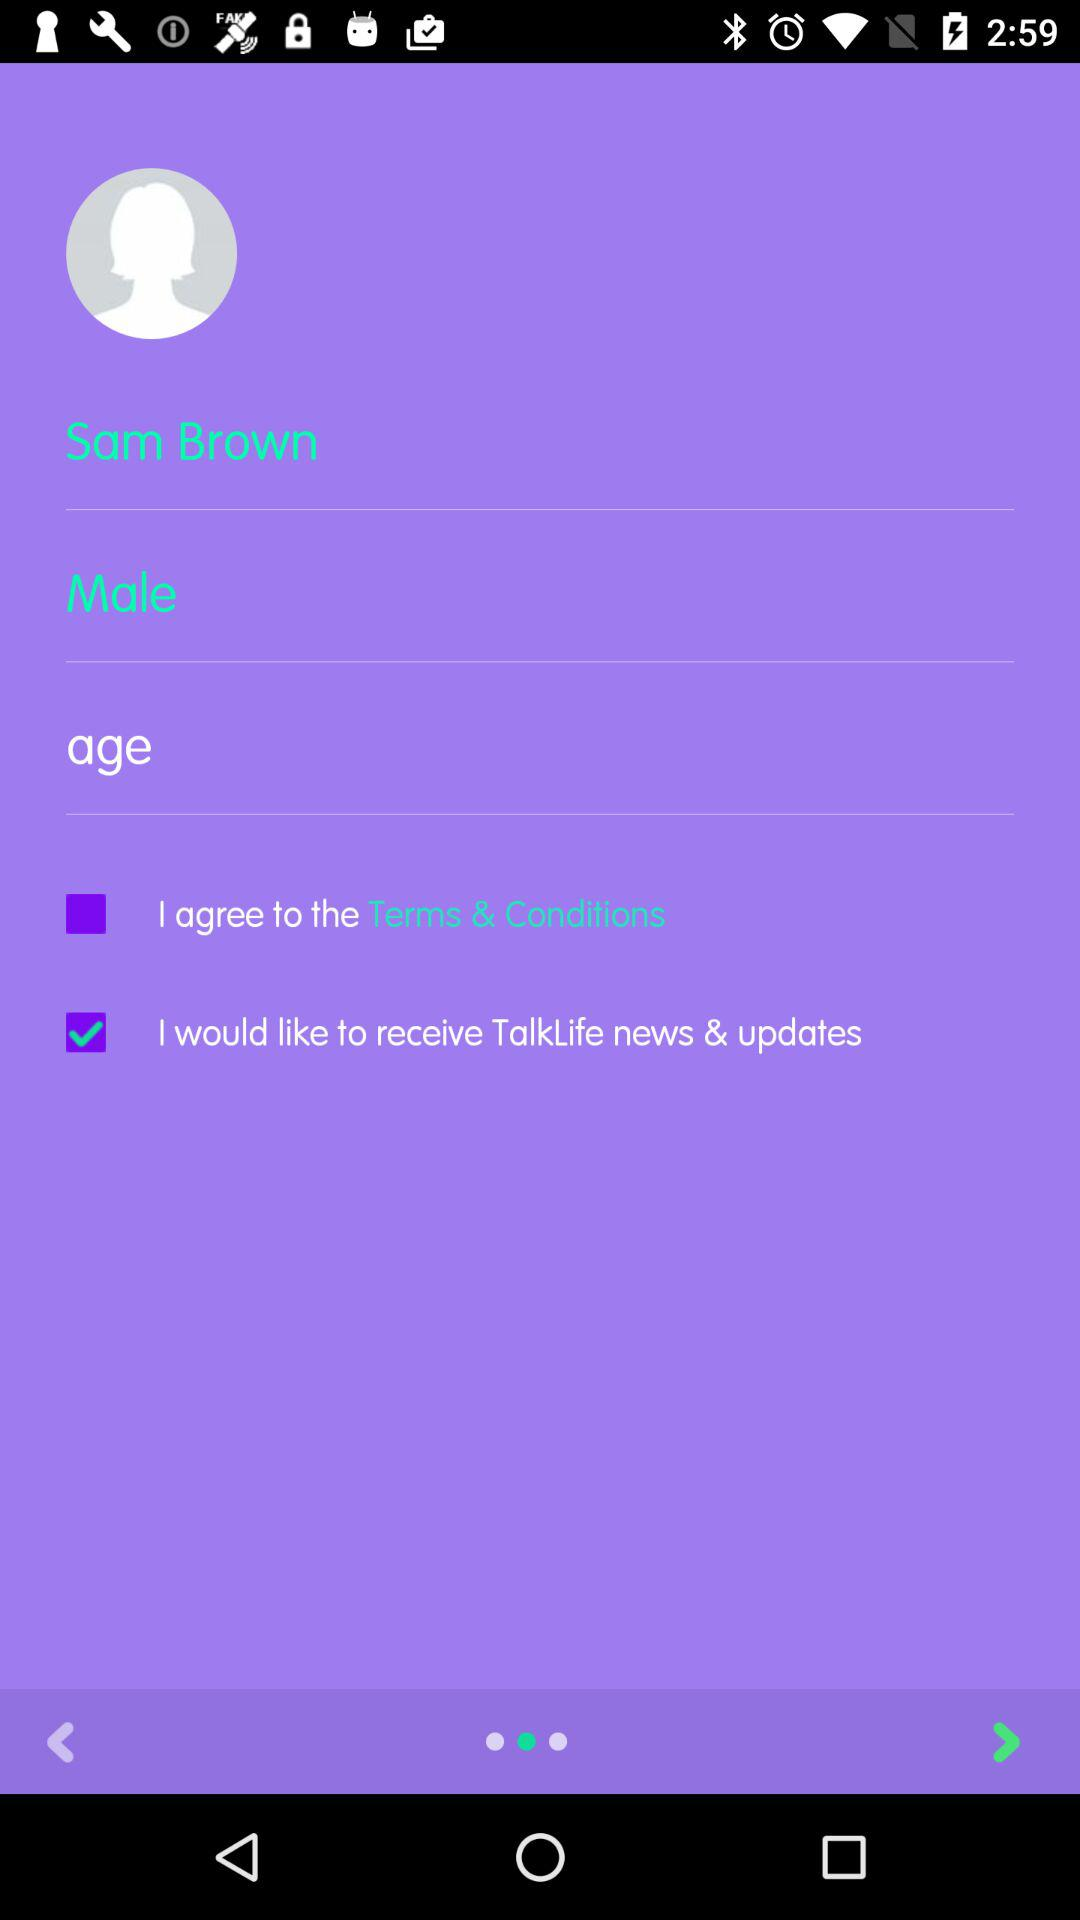Which gender is selected? The gender selected is Male. 